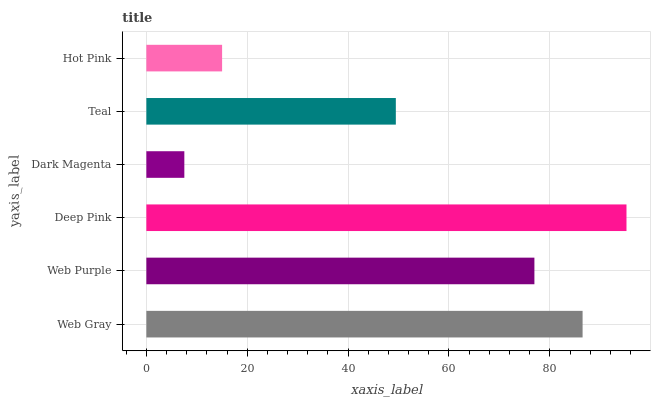Is Dark Magenta the minimum?
Answer yes or no. Yes. Is Deep Pink the maximum?
Answer yes or no. Yes. Is Web Purple the minimum?
Answer yes or no. No. Is Web Purple the maximum?
Answer yes or no. No. Is Web Gray greater than Web Purple?
Answer yes or no. Yes. Is Web Purple less than Web Gray?
Answer yes or no. Yes. Is Web Purple greater than Web Gray?
Answer yes or no. No. Is Web Gray less than Web Purple?
Answer yes or no. No. Is Web Purple the high median?
Answer yes or no. Yes. Is Teal the low median?
Answer yes or no. Yes. Is Web Gray the high median?
Answer yes or no. No. Is Web Purple the low median?
Answer yes or no. No. 